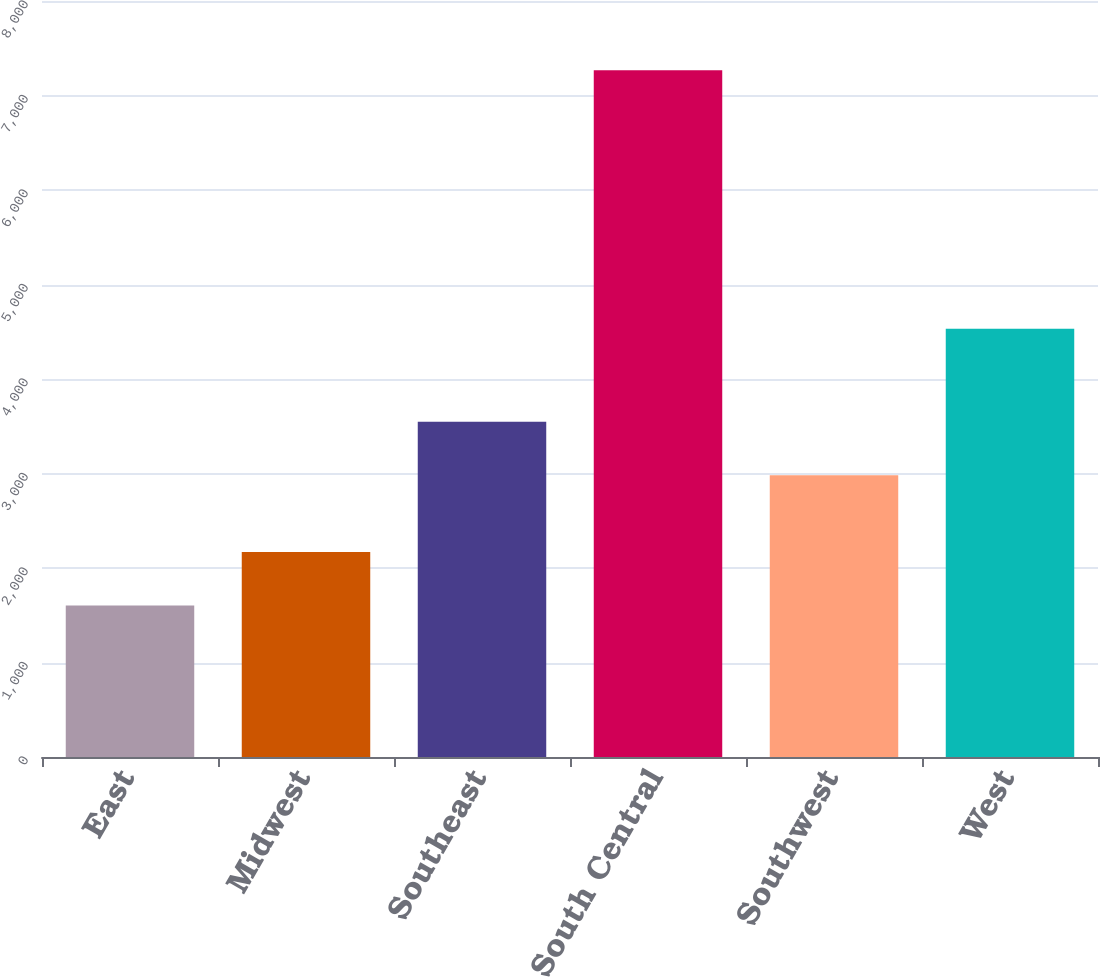Convert chart. <chart><loc_0><loc_0><loc_500><loc_500><bar_chart><fcel>East<fcel>Midwest<fcel>Southeast<fcel>South Central<fcel>Southwest<fcel>West<nl><fcel>1602<fcel>2168.4<fcel>3548.4<fcel>7266<fcel>2982<fcel>4533<nl></chart> 